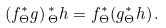Convert formula to latex. <formula><loc_0><loc_0><loc_500><loc_500>( f ^ { * } _ { \Theta } g ) \, ^ { * } _ { \Theta } h = f ^ { * } _ { \Theta } ( g ^ { * } _ { \Theta } h ) \, .</formula> 